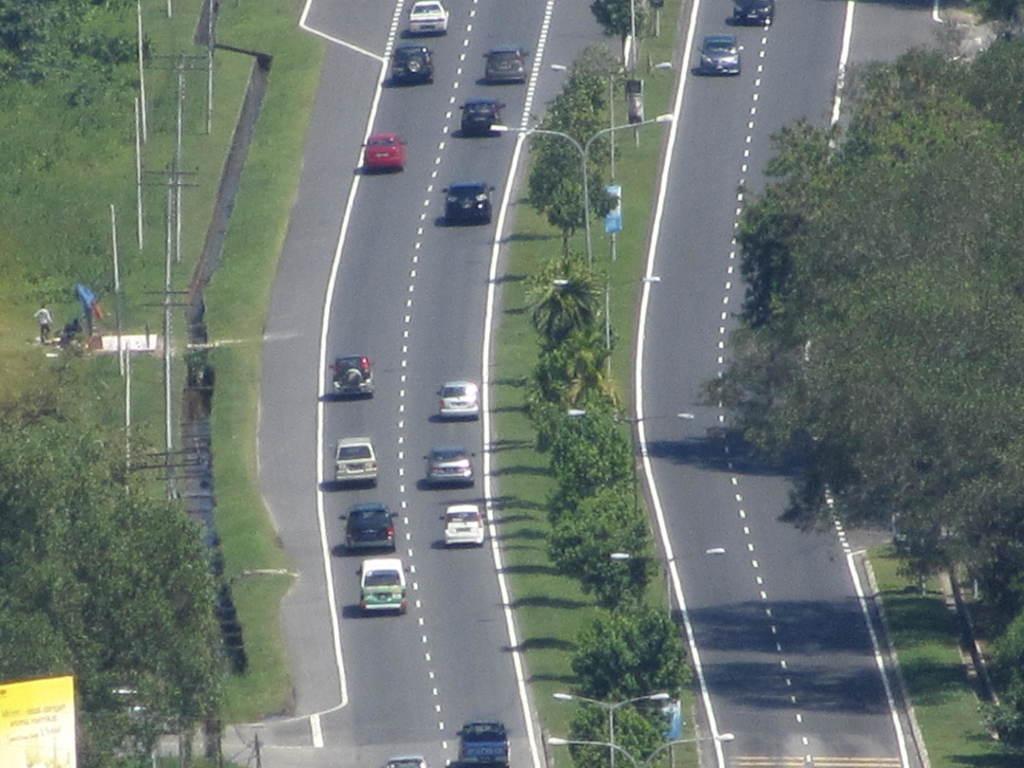Describe this image in one or two sentences. This image consists of road, on which there are many vehicles. To the left and right there are trees. To the bottom left there is a banner. In the middle, there are pole along with lights. 